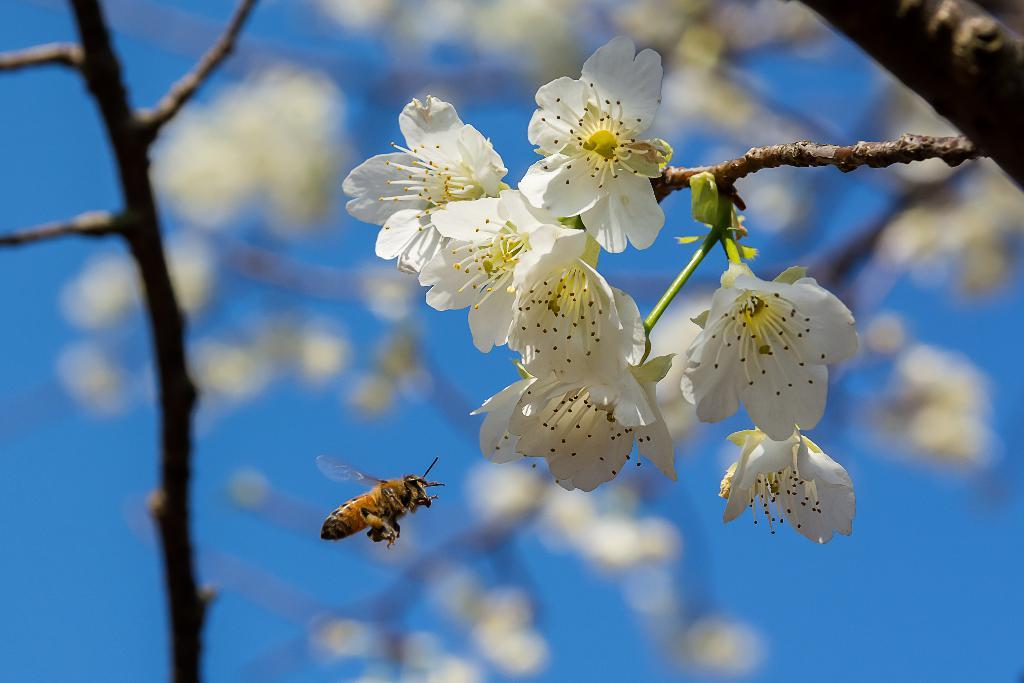What is the main subject of the image? There is a bunch of flowers in the image. How are the flowers connected to each other? The flowers are attached to a stem. What else can be seen in the image besides the flowers? There is an insect flying in the air in the image. Can you describe the background of the image? The background of the image appears blurry. What time of day is it in the image, and how does the tent contribute to the scene? There is no mention of time of day or a tent in the image. The image features a bunch of flowers, a stem, and an insect flying in the air. 